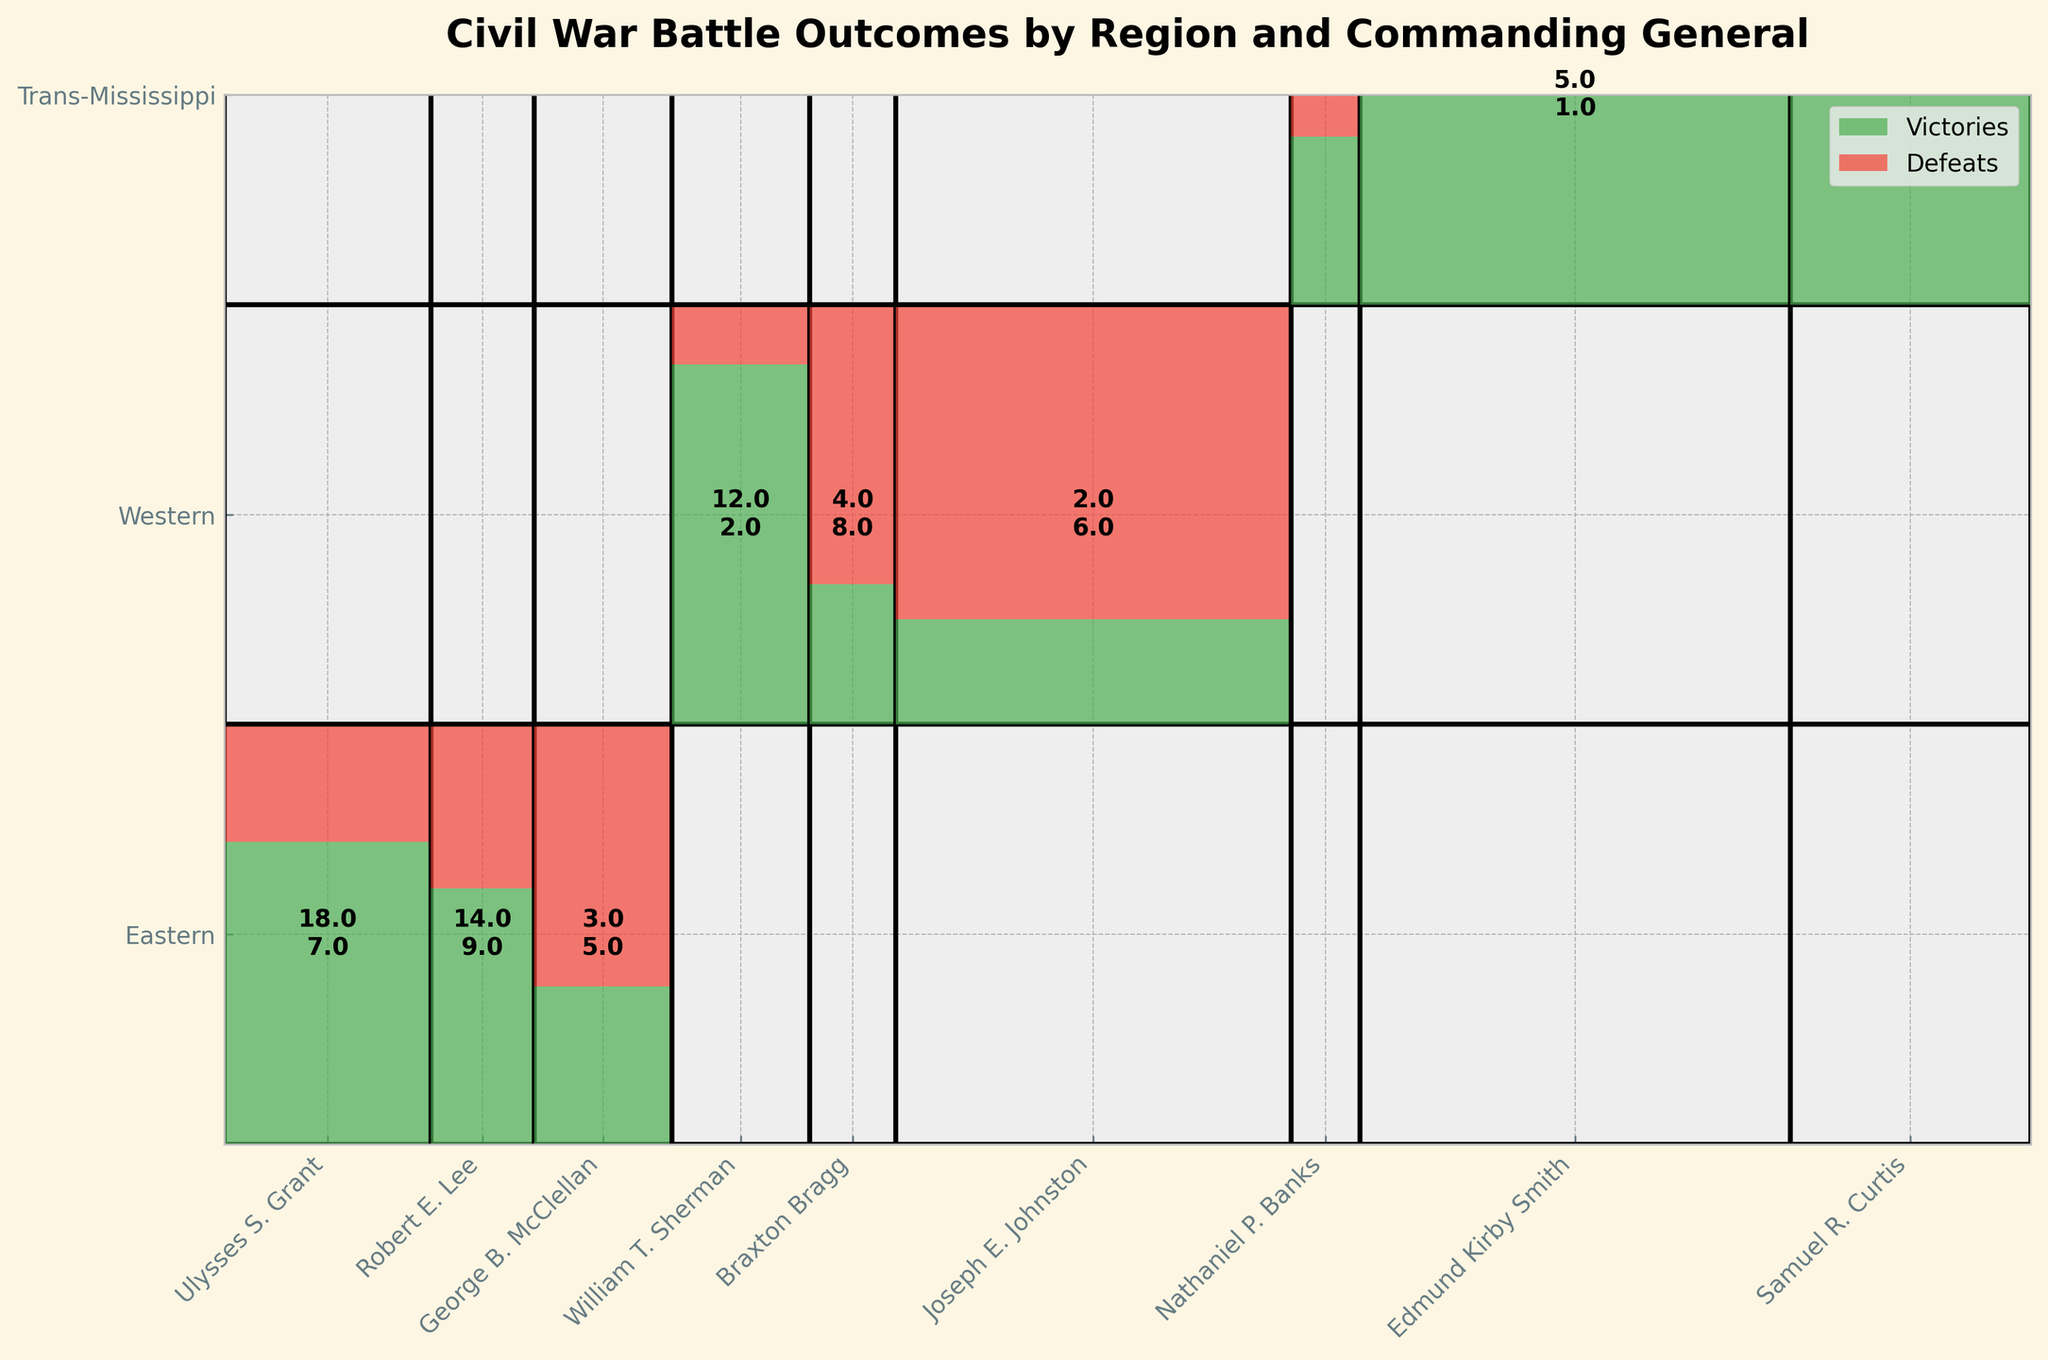What's the title of the figure? The title of the figure is prominently displayed at the top and reads "Civil War Battle Outcomes by Region and Commanding General".
Answer: Civil War Battle Outcomes by Region and Commanding General How many regions are represented in the figure? The y-axis of the figure labels the different regions, which are: Eastern, Western, and Trans-Mississippi, totaling three regions.
Answer: Three Which commanding general from the Eastern region achieved the most victories? In the Eastern region, the heights of the green sections indicating victories for the generals are Grant (18), Lee (14), and McClellan (3). The highest number, 18, is for Ulysses S. Grant.
Answer: Ulysses S. Grant How do the total number of battles (victories + defeats) compare between the commanding generals in the Western region? Adding victories and defeats for each general in the Western region: Sherman has 14 (12+2), Bragg has 12 (4+8), and Johnston has 8 (2+6). So, Sherman > Bragg > Johnston.
Answer: Sherman > Bragg > Johnston Which commander had the highest proportion of victories in the Western region? In the Western region, the proportions of victories to total battles for each general are Sherman (12/14 ≈ 0.857), Bragg (4/12 ≈ 0.333), and Johnston (2/8 ≈ 0.25). The highest proportion is for Sherman.
Answer: William T. Sherman Which region experienced the fewest defeats overall? Summing up the defeats for each region: Eastern (7+9+5 = 21), Western (2+8+6 = 16), and Trans-Mississippi (3+1+1 = 5). The fewest defeats are in the Trans-Mississippi region.
Answer: Trans-Mississippi By visual inspection, which general from the Trans-Mississippi region had the fewest total engagements (victories + defeats)? The heights of the rectangles representing battles for generals in the Trans-Mississippi region show that Curtis (3+1=4) had fewer engagements compared to Banks (2+3=5) and Smith (5+1=6).
Answer: Samuel R. Curtis How does the total number of victories in the Western region compare to the Eastern region? Summing up victories in the Western region (Sherman 12 + Bragg 4 + Johnston 2 = 18) and Eastern region (Grant 18 + Lee 14 + McClellan 3 = 35), the Eastern region has more total victories.
Answer: Eastern region has more Which general has the smallest green area indicating victories across all regions? By inspecting the smallest green area, Nathaniel P. Banks (Trans-Mississippi) with 2 victories seems to have the smallest segment.
Answer: Nathaniel P. Banks 